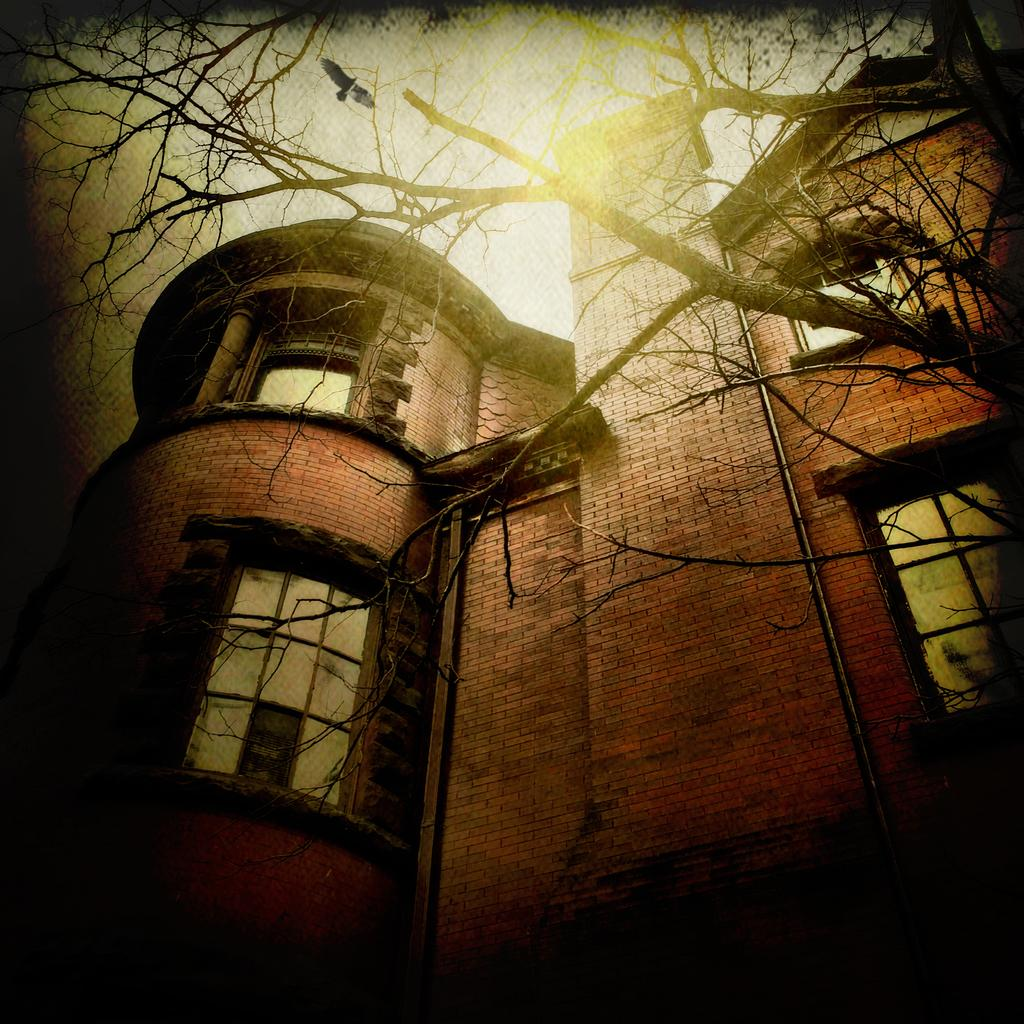What can you describe the editing done to the image? The image is edited, but the specific details of the editing are not mentioned in the provided facts. What type of structure is present in the image? There is a building in the image. What color is the building? The building is in red color. What can be seen at the top of the image? There is a tree on the top of the image. What is happening in the sky in the image? A bird is flying in the air in the image. How does the cave in the image affect the bird's flight? There is no cave present in the image; it only features a building, a tree, and a bird flying in the air. 